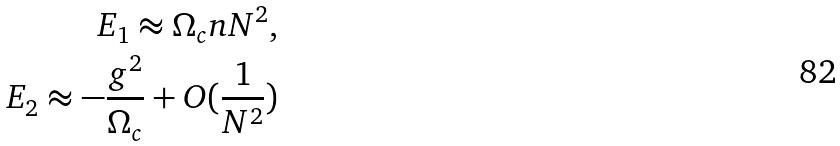Convert formula to latex. <formula><loc_0><loc_0><loc_500><loc_500>E _ { 1 } \approx \Omega _ { c } n N ^ { 2 } , \\ E _ { 2 } \approx - \frac { g ^ { 2 } } { \Omega _ { c } } + O ( \frac { 1 } { N ^ { 2 } } )</formula> 